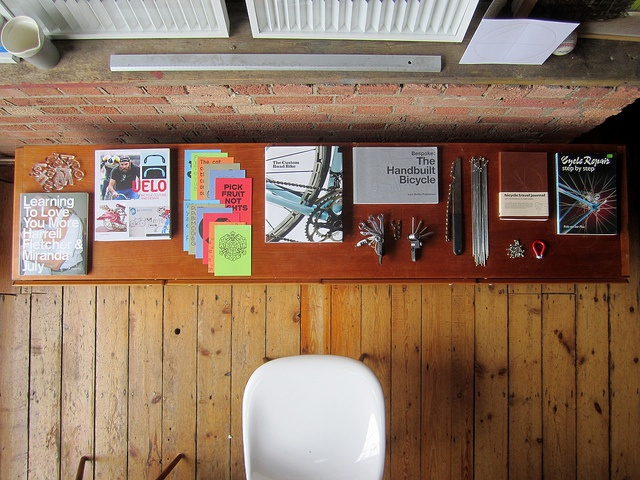Describe the objects in this image and their specific colors. I can see chair in gray, lightgray, and darkgray tones, book in gray, lightgray, darkgray, and black tones, bicycle in gray, lightgray, darkgray, and black tones, book in gray, lightgray, darkgray, and lightblue tones, and book in gray, lightgray, darkgray, and lightpink tones in this image. 